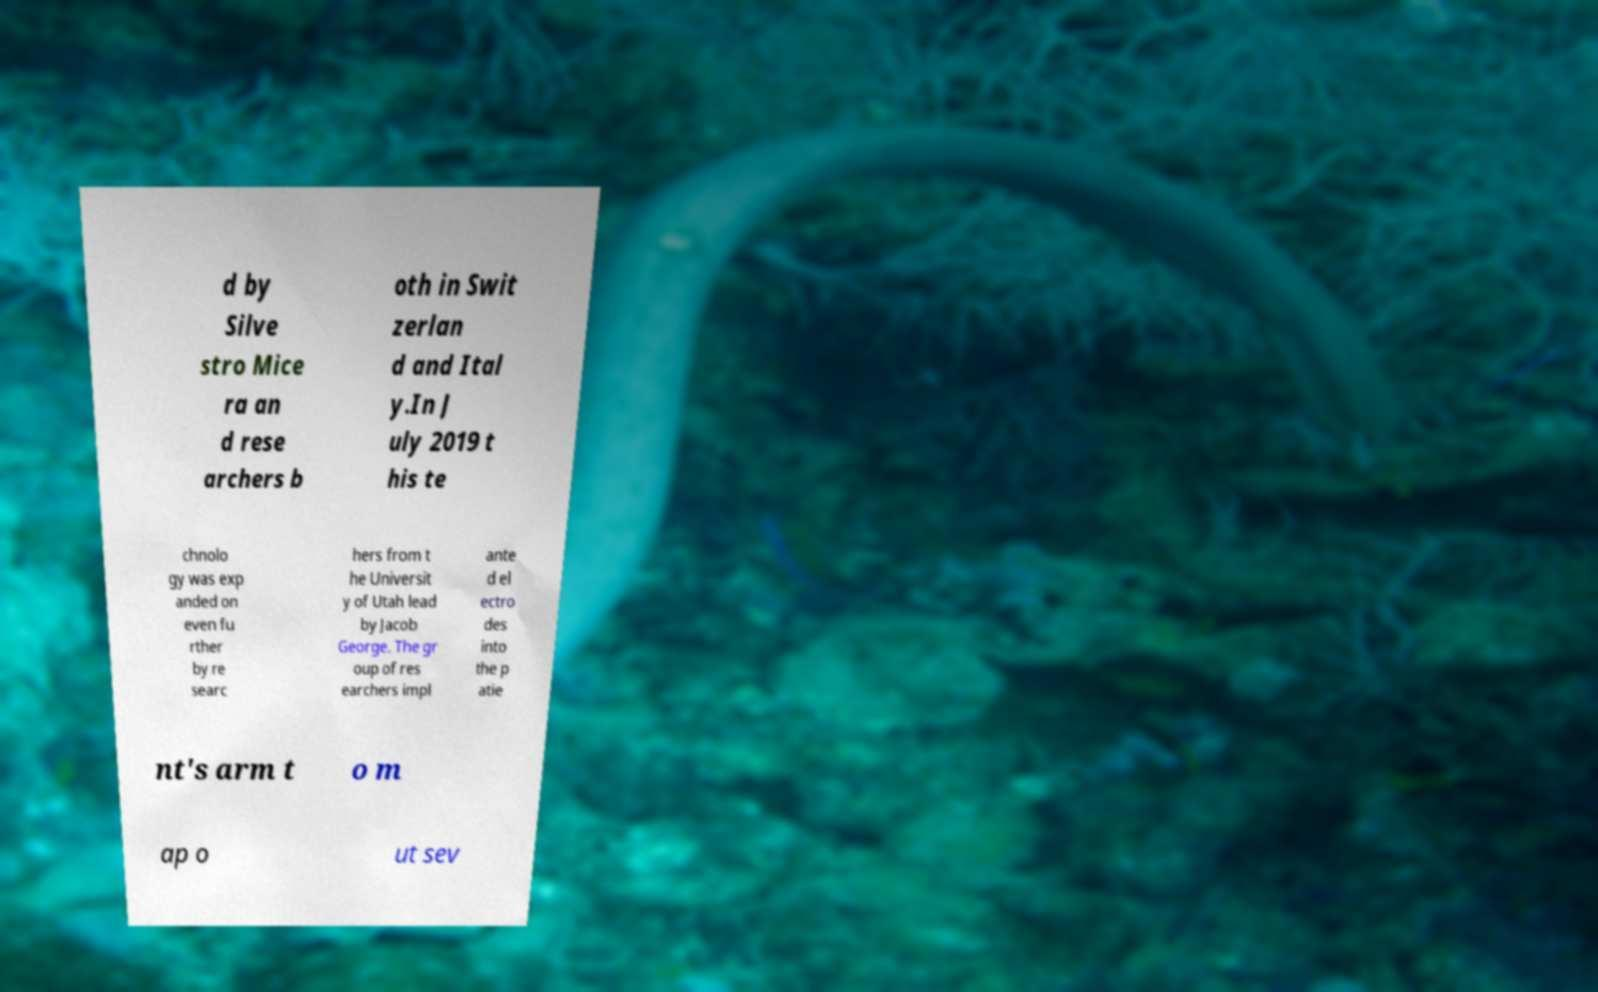Please read and relay the text visible in this image. What does it say? d by Silve stro Mice ra an d rese archers b oth in Swit zerlan d and Ital y.In J uly 2019 t his te chnolo gy was exp anded on even fu rther by re searc hers from t he Universit y of Utah lead by Jacob George. The gr oup of res earchers impl ante d el ectro des into the p atie nt's arm t o m ap o ut sev 